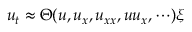Convert formula to latex. <formula><loc_0><loc_0><loc_500><loc_500>\begin{array} { r } { u _ { t } \approx \Theta ( u , u _ { x } , u _ { x x } , u u _ { x } , \cdots ) \xi } \end{array}</formula> 